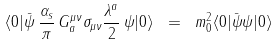Convert formula to latex. <formula><loc_0><loc_0><loc_500><loc_500>\langle 0 | \bar { \psi } \, \frac { \alpha _ { s } } \pi \, G ^ { \mu \nu } _ { a } \sigma _ { \mu \nu } \frac { \lambda ^ { a } } 2 \, \psi | 0 \rangle \ = \ m ^ { 2 } _ { 0 } \langle 0 | \bar { \psi } \psi | 0 \rangle</formula> 